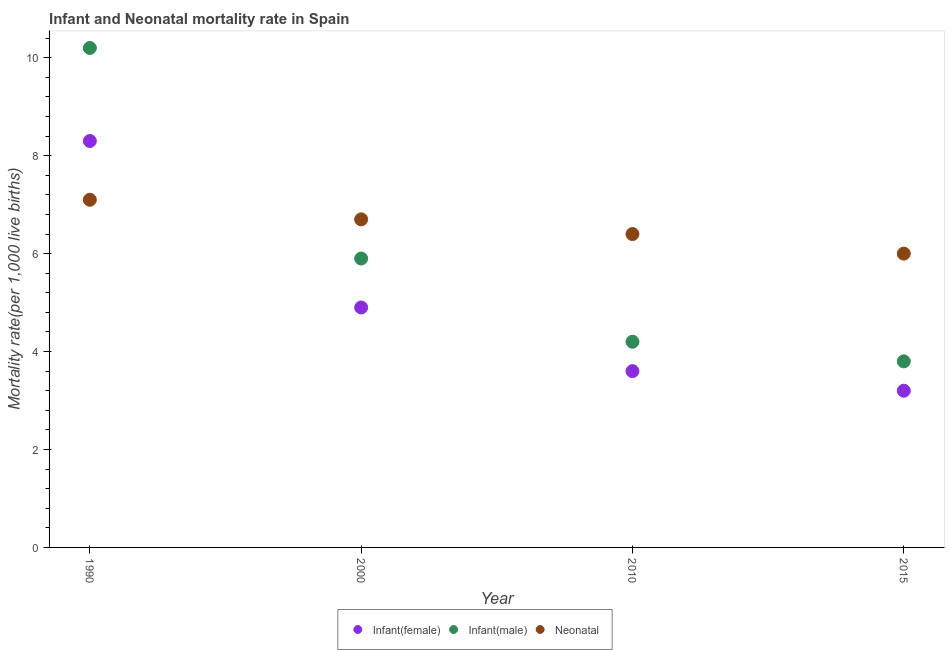How many different coloured dotlines are there?
Keep it short and to the point. 3. In which year was the infant mortality rate(male) minimum?
Make the answer very short. 2015. What is the total infant mortality rate(male) in the graph?
Provide a short and direct response. 24.1. What is the difference between the infant mortality rate(male) in 2000 and that in 2010?
Offer a terse response. 1.7. What is the average infant mortality rate(male) per year?
Offer a very short reply. 6.03. In the year 1990, what is the difference between the infant mortality rate(male) and neonatal mortality rate?
Your answer should be compact. 3.1. What is the ratio of the neonatal mortality rate in 2000 to that in 2015?
Offer a very short reply. 1.12. Is the neonatal mortality rate in 2000 less than that in 2010?
Offer a terse response. No. Is the difference between the neonatal mortality rate in 2010 and 2015 greater than the difference between the infant mortality rate(male) in 2010 and 2015?
Provide a short and direct response. No. What is the difference between the highest and the second highest infant mortality rate(male)?
Make the answer very short. 4.3. What is the difference between the highest and the lowest neonatal mortality rate?
Make the answer very short. 1.1. In how many years, is the neonatal mortality rate greater than the average neonatal mortality rate taken over all years?
Make the answer very short. 2. Is it the case that in every year, the sum of the infant mortality rate(female) and infant mortality rate(male) is greater than the neonatal mortality rate?
Give a very brief answer. Yes. Does the infant mortality rate(male) monotonically increase over the years?
Offer a very short reply. No. How many dotlines are there?
Give a very brief answer. 3. How many years are there in the graph?
Offer a very short reply. 4. Are the values on the major ticks of Y-axis written in scientific E-notation?
Provide a succinct answer. No. Does the graph contain any zero values?
Offer a very short reply. No. Where does the legend appear in the graph?
Ensure brevity in your answer.  Bottom center. How many legend labels are there?
Offer a terse response. 3. How are the legend labels stacked?
Keep it short and to the point. Horizontal. What is the title of the graph?
Your answer should be very brief. Infant and Neonatal mortality rate in Spain. What is the label or title of the Y-axis?
Provide a succinct answer. Mortality rate(per 1,0 live births). What is the Mortality rate(per 1,000 live births) in Infant(female) in 1990?
Offer a very short reply. 8.3. What is the Mortality rate(per 1,000 live births) of Infant(male) in 2000?
Keep it short and to the point. 5.9. What is the Mortality rate(per 1,000 live births) in Neonatal  in 2000?
Your answer should be very brief. 6.7. What is the Mortality rate(per 1,000 live births) of Infant(female) in 2010?
Offer a terse response. 3.6. What is the Mortality rate(per 1,000 live births) of Infant(male) in 2010?
Keep it short and to the point. 4.2. What is the Mortality rate(per 1,000 live births) in Neonatal  in 2010?
Offer a very short reply. 6.4. What is the Mortality rate(per 1,000 live births) of Infant(female) in 2015?
Offer a terse response. 3.2. What is the Mortality rate(per 1,000 live births) in Infant(male) in 2015?
Make the answer very short. 3.8. Across all years, what is the maximum Mortality rate(per 1,000 live births) of Infant(male)?
Your answer should be compact. 10.2. Across all years, what is the minimum Mortality rate(per 1,000 live births) in Infant(male)?
Provide a succinct answer. 3.8. Across all years, what is the minimum Mortality rate(per 1,000 live births) in Neonatal ?
Ensure brevity in your answer.  6. What is the total Mortality rate(per 1,000 live births) in Infant(male) in the graph?
Your answer should be compact. 24.1. What is the total Mortality rate(per 1,000 live births) in Neonatal  in the graph?
Provide a short and direct response. 26.2. What is the difference between the Mortality rate(per 1,000 live births) in Infant(male) in 1990 and that in 2010?
Your answer should be very brief. 6. What is the difference between the Mortality rate(per 1,000 live births) of Neonatal  in 1990 and that in 2010?
Offer a very short reply. 0.7. What is the difference between the Mortality rate(per 1,000 live births) of Infant(female) in 1990 and that in 2015?
Your answer should be very brief. 5.1. What is the difference between the Mortality rate(per 1,000 live births) of Neonatal  in 1990 and that in 2015?
Offer a very short reply. 1.1. What is the difference between the Mortality rate(per 1,000 live births) of Infant(male) in 2000 and that in 2010?
Ensure brevity in your answer.  1.7. What is the difference between the Mortality rate(per 1,000 live births) of Infant(female) in 2000 and that in 2015?
Provide a succinct answer. 1.7. What is the difference between the Mortality rate(per 1,000 live births) in Infant(male) in 2000 and that in 2015?
Make the answer very short. 2.1. What is the difference between the Mortality rate(per 1,000 live births) in Neonatal  in 2000 and that in 2015?
Provide a succinct answer. 0.7. What is the difference between the Mortality rate(per 1,000 live births) of Infant(female) in 2010 and that in 2015?
Provide a succinct answer. 0.4. What is the difference between the Mortality rate(per 1,000 live births) in Infant(male) in 2010 and that in 2015?
Ensure brevity in your answer.  0.4. What is the difference between the Mortality rate(per 1,000 live births) in Infant(female) in 1990 and the Mortality rate(per 1,000 live births) in Infant(male) in 2000?
Your response must be concise. 2.4. What is the difference between the Mortality rate(per 1,000 live births) in Infant(female) in 1990 and the Mortality rate(per 1,000 live births) in Neonatal  in 2000?
Make the answer very short. 1.6. What is the difference between the Mortality rate(per 1,000 live births) in Infant(female) in 1990 and the Mortality rate(per 1,000 live births) in Infant(male) in 2010?
Your answer should be very brief. 4.1. What is the difference between the Mortality rate(per 1,000 live births) of Infant(male) in 1990 and the Mortality rate(per 1,000 live births) of Neonatal  in 2010?
Give a very brief answer. 3.8. What is the difference between the Mortality rate(per 1,000 live births) in Infant(female) in 1990 and the Mortality rate(per 1,000 live births) in Infant(male) in 2015?
Provide a succinct answer. 4.5. What is the difference between the Mortality rate(per 1,000 live births) in Infant(female) in 1990 and the Mortality rate(per 1,000 live births) in Neonatal  in 2015?
Offer a terse response. 2.3. What is the difference between the Mortality rate(per 1,000 live births) in Infant(male) in 1990 and the Mortality rate(per 1,000 live births) in Neonatal  in 2015?
Give a very brief answer. 4.2. What is the difference between the Mortality rate(per 1,000 live births) in Infant(female) in 2000 and the Mortality rate(per 1,000 live births) in Neonatal  in 2015?
Keep it short and to the point. -1.1. What is the difference between the Mortality rate(per 1,000 live births) of Infant(male) in 2000 and the Mortality rate(per 1,000 live births) of Neonatal  in 2015?
Provide a succinct answer. -0.1. What is the difference between the Mortality rate(per 1,000 live births) of Infant(female) in 2010 and the Mortality rate(per 1,000 live births) of Infant(male) in 2015?
Make the answer very short. -0.2. What is the difference between the Mortality rate(per 1,000 live births) of Infant(male) in 2010 and the Mortality rate(per 1,000 live births) of Neonatal  in 2015?
Make the answer very short. -1.8. What is the average Mortality rate(per 1,000 live births) in Infant(female) per year?
Your answer should be very brief. 5. What is the average Mortality rate(per 1,000 live births) in Infant(male) per year?
Keep it short and to the point. 6.03. What is the average Mortality rate(per 1,000 live births) in Neonatal  per year?
Provide a succinct answer. 6.55. In the year 1990, what is the difference between the Mortality rate(per 1,000 live births) in Infant(female) and Mortality rate(per 1,000 live births) in Neonatal ?
Provide a short and direct response. 1.2. In the year 2000, what is the difference between the Mortality rate(per 1,000 live births) in Infant(female) and Mortality rate(per 1,000 live births) in Infant(male)?
Provide a short and direct response. -1. In the year 2000, what is the difference between the Mortality rate(per 1,000 live births) in Infant(male) and Mortality rate(per 1,000 live births) in Neonatal ?
Provide a short and direct response. -0.8. In the year 2010, what is the difference between the Mortality rate(per 1,000 live births) of Infant(female) and Mortality rate(per 1,000 live births) of Infant(male)?
Your answer should be compact. -0.6. In the year 2010, what is the difference between the Mortality rate(per 1,000 live births) in Infant(male) and Mortality rate(per 1,000 live births) in Neonatal ?
Make the answer very short. -2.2. In the year 2015, what is the difference between the Mortality rate(per 1,000 live births) in Infant(female) and Mortality rate(per 1,000 live births) in Neonatal ?
Give a very brief answer. -2.8. In the year 2015, what is the difference between the Mortality rate(per 1,000 live births) of Infant(male) and Mortality rate(per 1,000 live births) of Neonatal ?
Your answer should be very brief. -2.2. What is the ratio of the Mortality rate(per 1,000 live births) of Infant(female) in 1990 to that in 2000?
Ensure brevity in your answer.  1.69. What is the ratio of the Mortality rate(per 1,000 live births) in Infant(male) in 1990 to that in 2000?
Provide a succinct answer. 1.73. What is the ratio of the Mortality rate(per 1,000 live births) of Neonatal  in 1990 to that in 2000?
Ensure brevity in your answer.  1.06. What is the ratio of the Mortality rate(per 1,000 live births) in Infant(female) in 1990 to that in 2010?
Your answer should be compact. 2.31. What is the ratio of the Mortality rate(per 1,000 live births) of Infant(male) in 1990 to that in 2010?
Make the answer very short. 2.43. What is the ratio of the Mortality rate(per 1,000 live births) in Neonatal  in 1990 to that in 2010?
Provide a succinct answer. 1.11. What is the ratio of the Mortality rate(per 1,000 live births) of Infant(female) in 1990 to that in 2015?
Your answer should be very brief. 2.59. What is the ratio of the Mortality rate(per 1,000 live births) of Infant(male) in 1990 to that in 2015?
Provide a short and direct response. 2.68. What is the ratio of the Mortality rate(per 1,000 live births) of Neonatal  in 1990 to that in 2015?
Keep it short and to the point. 1.18. What is the ratio of the Mortality rate(per 1,000 live births) of Infant(female) in 2000 to that in 2010?
Make the answer very short. 1.36. What is the ratio of the Mortality rate(per 1,000 live births) of Infant(male) in 2000 to that in 2010?
Provide a succinct answer. 1.4. What is the ratio of the Mortality rate(per 1,000 live births) in Neonatal  in 2000 to that in 2010?
Ensure brevity in your answer.  1.05. What is the ratio of the Mortality rate(per 1,000 live births) of Infant(female) in 2000 to that in 2015?
Your response must be concise. 1.53. What is the ratio of the Mortality rate(per 1,000 live births) in Infant(male) in 2000 to that in 2015?
Make the answer very short. 1.55. What is the ratio of the Mortality rate(per 1,000 live births) of Neonatal  in 2000 to that in 2015?
Make the answer very short. 1.12. What is the ratio of the Mortality rate(per 1,000 live births) of Infant(female) in 2010 to that in 2015?
Offer a very short reply. 1.12. What is the ratio of the Mortality rate(per 1,000 live births) in Infant(male) in 2010 to that in 2015?
Provide a short and direct response. 1.11. What is the ratio of the Mortality rate(per 1,000 live births) of Neonatal  in 2010 to that in 2015?
Your answer should be very brief. 1.07. What is the difference between the highest and the second highest Mortality rate(per 1,000 live births) of Infant(male)?
Give a very brief answer. 4.3. What is the difference between the highest and the second highest Mortality rate(per 1,000 live births) of Neonatal ?
Provide a short and direct response. 0.4. What is the difference between the highest and the lowest Mortality rate(per 1,000 live births) in Neonatal ?
Your answer should be compact. 1.1. 